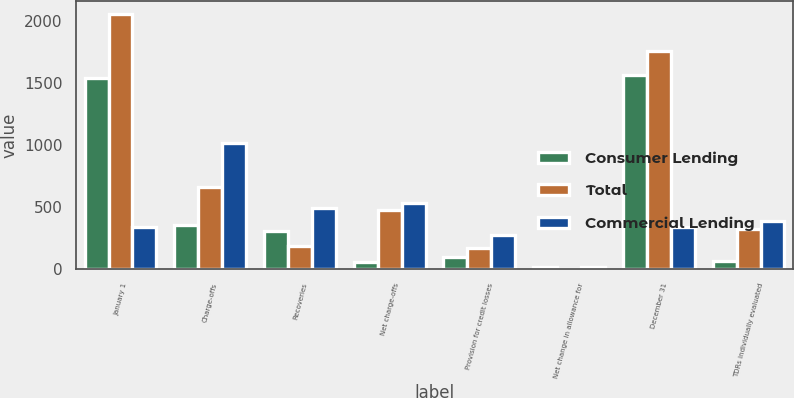Convert chart to OTSL. <chart><loc_0><loc_0><loc_500><loc_500><stacked_bar_chart><ecel><fcel>January 1<fcel>Charge-offs<fcel>Recoveries<fcel>Net charge-offs<fcel>Provision for credit losses<fcel>Net change in allowance for<fcel>December 31<fcel>TDRs individually evaluated<nl><fcel>Consumer Lending<fcel>1547<fcel>360<fcel>305<fcel>55<fcel>100<fcel>18<fcel>1571<fcel>62<nl><fcel>Total<fcel>2062<fcel>661<fcel>185<fcel>476<fcel>173<fcel>1<fcel>1760<fcel>324<nl><fcel>Commercial Lending<fcel>342<fcel>1021<fcel>490<fcel>531<fcel>273<fcel>17<fcel>342<fcel>386<nl></chart> 